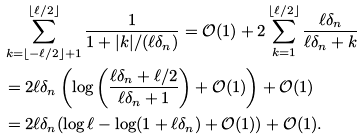<formula> <loc_0><loc_0><loc_500><loc_500>& \sum _ { k = \lfloor - \ell / 2 \rfloor + 1 } ^ { \lfloor \ell / 2 \rfloor } \frac { 1 } { 1 + | k | / ( \ell \delta _ { n } ) } = \mathcal { O } ( 1 ) + 2 \sum _ { k = 1 } ^ { \lfloor \ell / 2 \rfloor } \frac { \ell \delta _ { n } } { \ell \delta _ { n } + k } \\ & = 2 \ell \delta _ { n } \left ( \log \left ( \frac { \ell \delta _ { n } + \ell / 2 } { \ell \delta _ { n } + 1 } \right ) + \mathcal { O } ( 1 ) \right ) + \mathcal { O } ( 1 ) \\ & = 2 \ell \delta _ { n } ( \log \ell - \log ( 1 + \ell \delta _ { n } ) + \mathcal { O } ( 1 ) ) + \mathcal { O } ( 1 ) .</formula> 